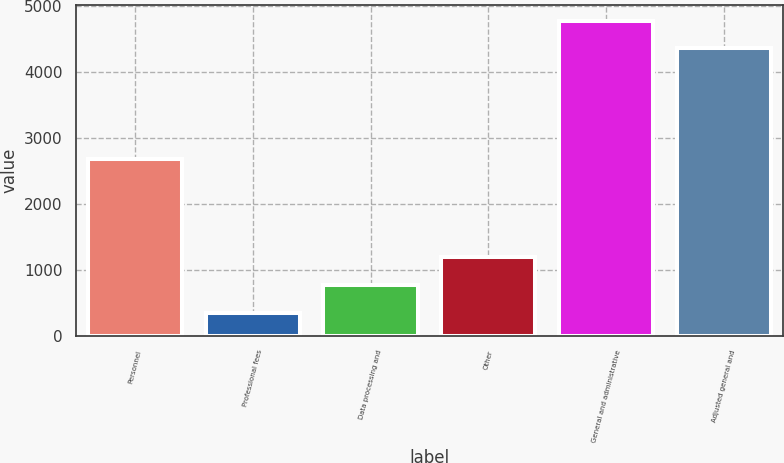Convert chart. <chart><loc_0><loc_0><loc_500><loc_500><bar_chart><fcel>Personnel<fcel>Professional fees<fcel>Data processing and<fcel>Other<fcel>General and administrative<fcel>Adjusted general and<nl><fcel>2687<fcel>355<fcel>772.1<fcel>1189.2<fcel>4776.1<fcel>4359<nl></chart> 